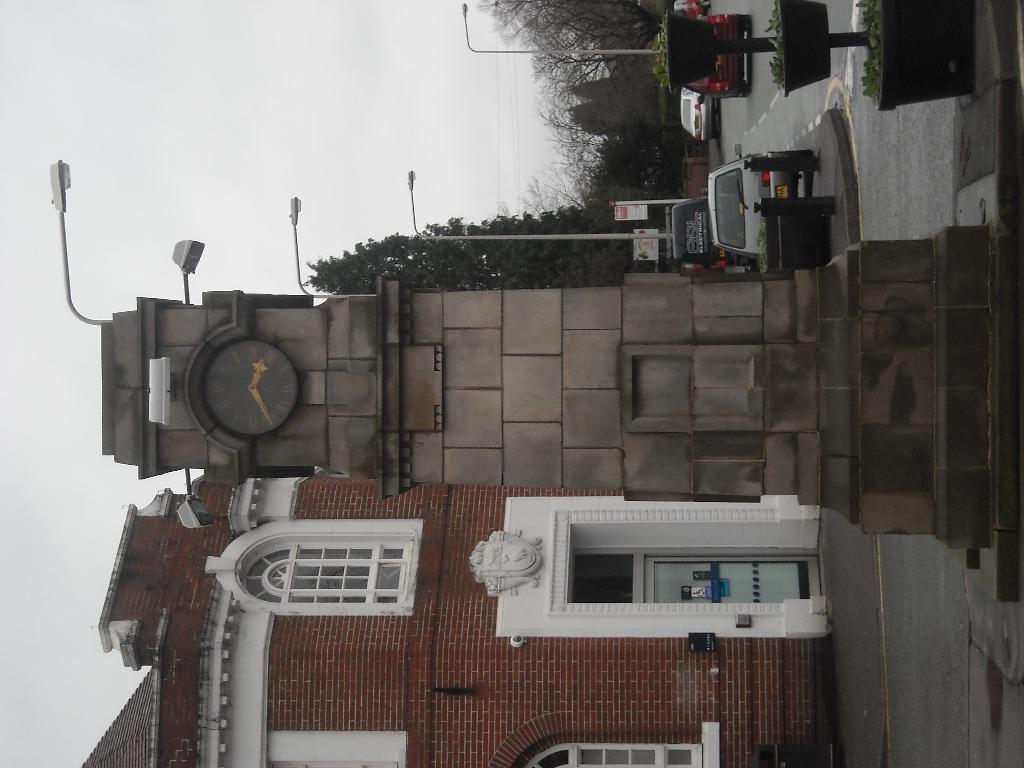Can you describe this image briefly? In this picture we can see clock tower, vehicles on the road, building, light poles, trees, plants with pots and boards. In the background of the image we can see the sky. 